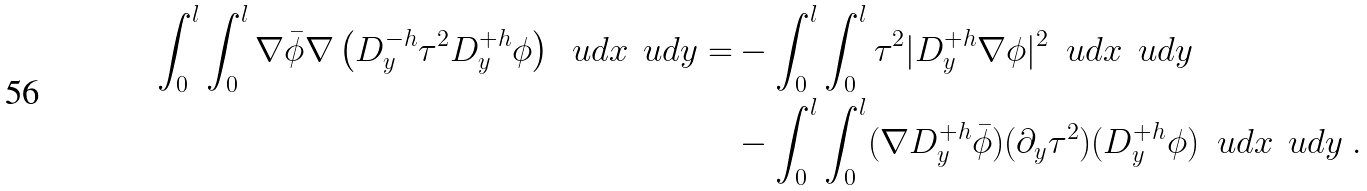<formula> <loc_0><loc_0><loc_500><loc_500>\int _ { 0 } ^ { l } \int _ { 0 } ^ { l } \nabla \bar { \phi } \nabla \left ( D ^ { - h } _ { y } \tau ^ { 2 } D ^ { + h } _ { y } \phi \right ) \ \ u d x \, \ u d y = & - \int _ { 0 } ^ { l } \int _ { 0 } ^ { l } \tau ^ { 2 } | D ^ { + h } _ { y } \nabla \phi | ^ { 2 } \ \ u d x \, \ u d y \\ & - \int _ { 0 } ^ { l } \int _ { 0 } ^ { l } ( \nabla D ^ { + h } _ { y } \bar { \phi } ) ( \partial _ { y } \tau ^ { 2 } ) ( D ^ { + h } _ { y } \phi ) \ \ u d x \, \ u d y \ .</formula> 